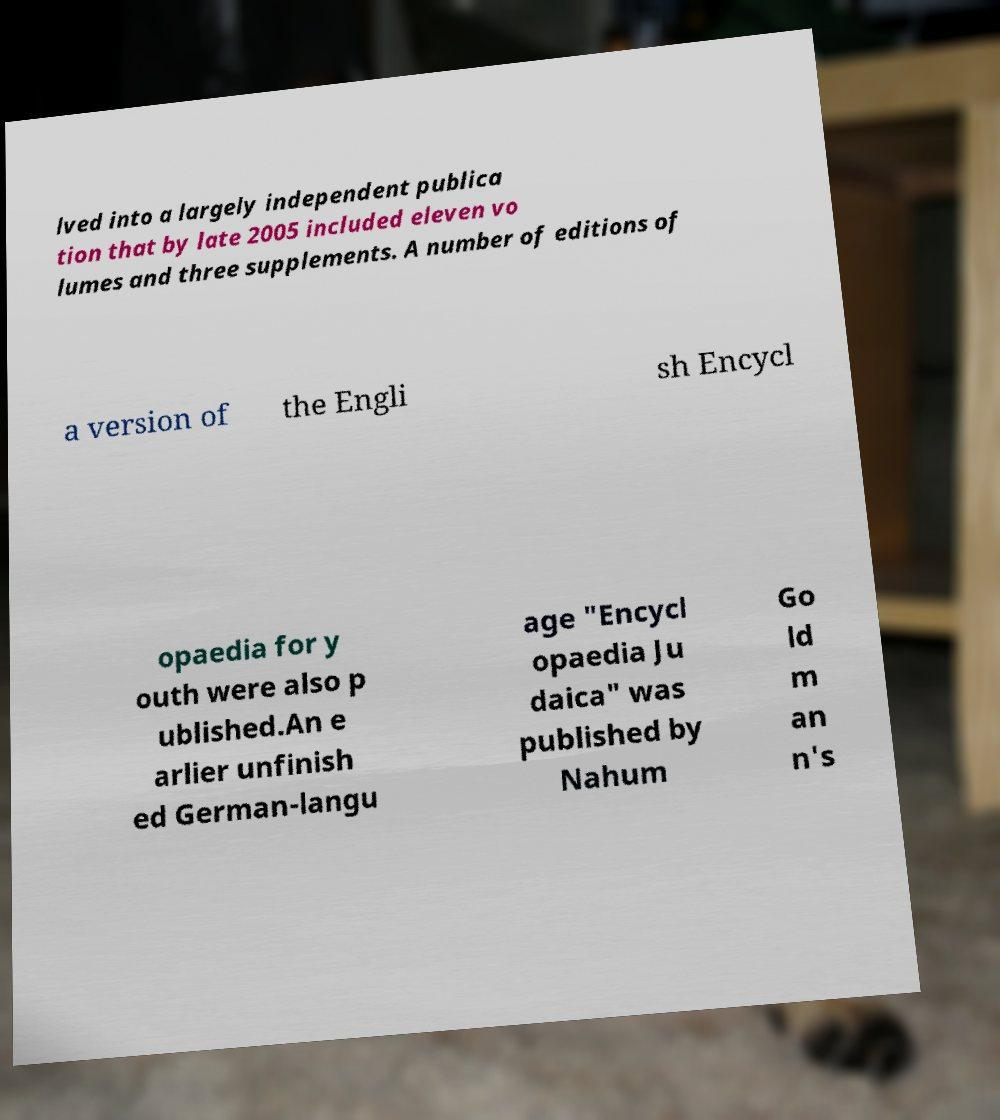Please identify and transcribe the text found in this image. lved into a largely independent publica tion that by late 2005 included eleven vo lumes and three supplements. A number of editions of a version of the Engli sh Encycl opaedia for y outh were also p ublished.An e arlier unfinish ed German-langu age "Encycl opaedia Ju daica" was published by Nahum Go ld m an n's 